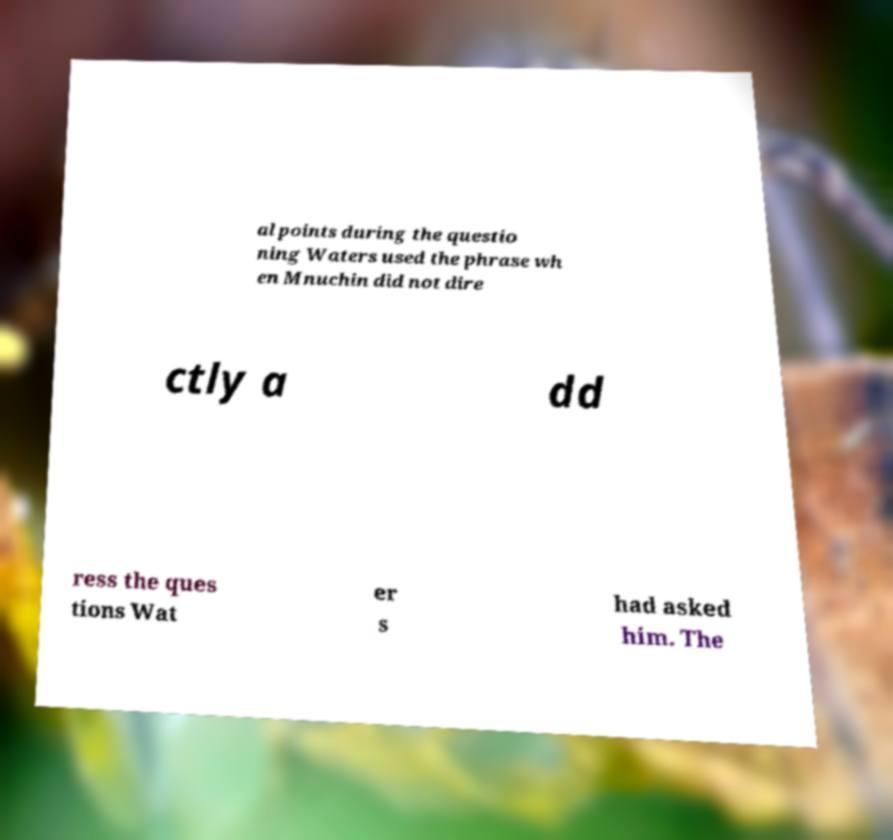Can you accurately transcribe the text from the provided image for me? al points during the questio ning Waters used the phrase wh en Mnuchin did not dire ctly a dd ress the ques tions Wat er s had asked him. The 